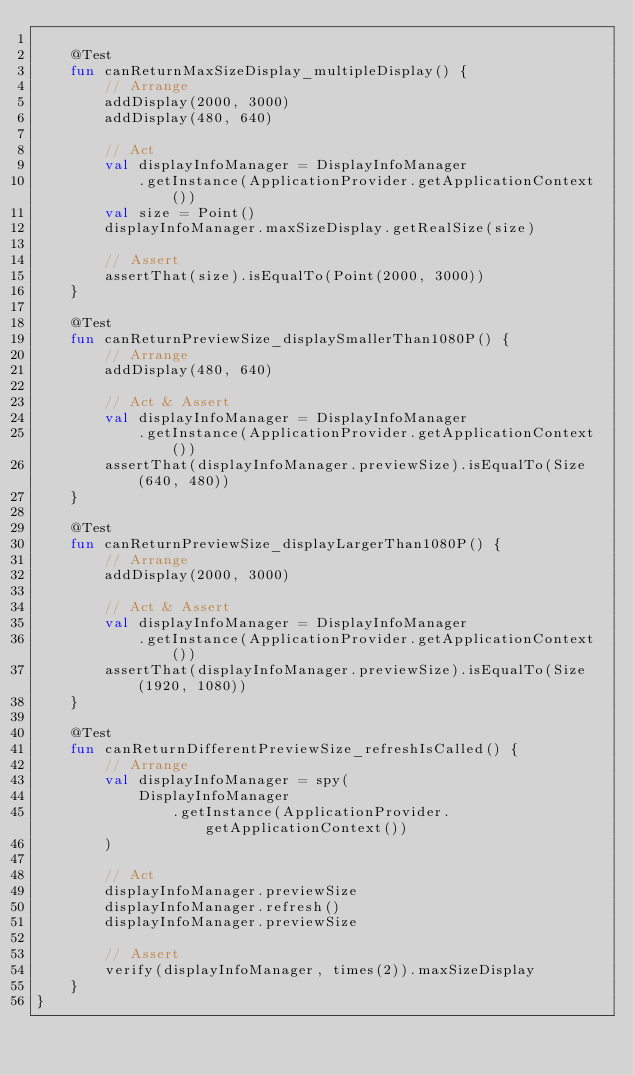<code> <loc_0><loc_0><loc_500><loc_500><_Kotlin_>
    @Test
    fun canReturnMaxSizeDisplay_multipleDisplay() {
        // Arrange
        addDisplay(2000, 3000)
        addDisplay(480, 640)

        // Act
        val displayInfoManager = DisplayInfoManager
            .getInstance(ApplicationProvider.getApplicationContext())
        val size = Point()
        displayInfoManager.maxSizeDisplay.getRealSize(size)

        // Assert
        assertThat(size).isEqualTo(Point(2000, 3000))
    }

    @Test
    fun canReturnPreviewSize_displaySmallerThan1080P() {
        // Arrange
        addDisplay(480, 640)

        // Act & Assert
        val displayInfoManager = DisplayInfoManager
            .getInstance(ApplicationProvider.getApplicationContext())
        assertThat(displayInfoManager.previewSize).isEqualTo(Size(640, 480))
    }

    @Test
    fun canReturnPreviewSize_displayLargerThan1080P() {
        // Arrange
        addDisplay(2000, 3000)

        // Act & Assert
        val displayInfoManager = DisplayInfoManager
            .getInstance(ApplicationProvider.getApplicationContext())
        assertThat(displayInfoManager.previewSize).isEqualTo(Size(1920, 1080))
    }

    @Test
    fun canReturnDifferentPreviewSize_refreshIsCalled() {
        // Arrange
        val displayInfoManager = spy(
            DisplayInfoManager
                .getInstance(ApplicationProvider.getApplicationContext())
        )

        // Act
        displayInfoManager.previewSize
        displayInfoManager.refresh()
        displayInfoManager.previewSize

        // Assert
        verify(displayInfoManager, times(2)).maxSizeDisplay
    }
}</code> 